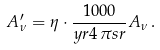<formula> <loc_0><loc_0><loc_500><loc_500>A _ { \nu } ^ { \prime } = \eta \cdot \frac { 1 0 0 0 } { y r 4 \, \pi s r } A _ { \nu } \, .</formula> 